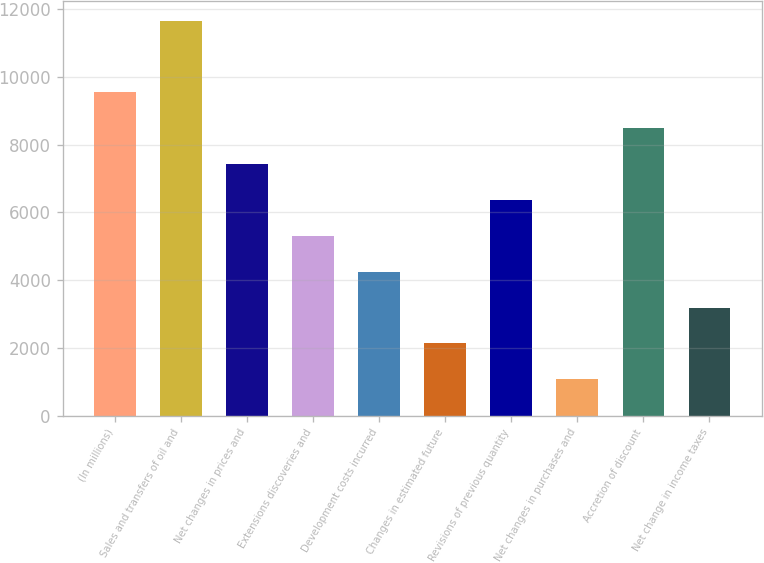Convert chart to OTSL. <chart><loc_0><loc_0><loc_500><loc_500><bar_chart><fcel>(In millions)<fcel>Sales and transfers of oil and<fcel>Net changes in prices and<fcel>Extensions discoveries and<fcel>Development costs incurred<fcel>Changes in estimated future<fcel>Revisions of previous quantity<fcel>Net changes in purchases and<fcel>Accretion of discount<fcel>Net change in income taxes<nl><fcel>9542.3<fcel>11659.7<fcel>7424.9<fcel>5307.5<fcel>4248.8<fcel>2131.4<fcel>6366.2<fcel>1072.7<fcel>8483.6<fcel>3190.1<nl></chart> 